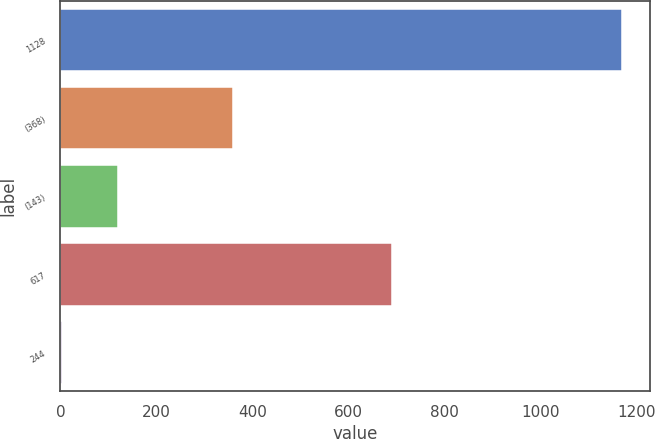Convert chart to OTSL. <chart><loc_0><loc_0><loc_500><loc_500><bar_chart><fcel>1128<fcel>(368)<fcel>(143)<fcel>617<fcel>244<nl><fcel>1171<fcel>359<fcel>120<fcel>692<fcel>2.77<nl></chart> 